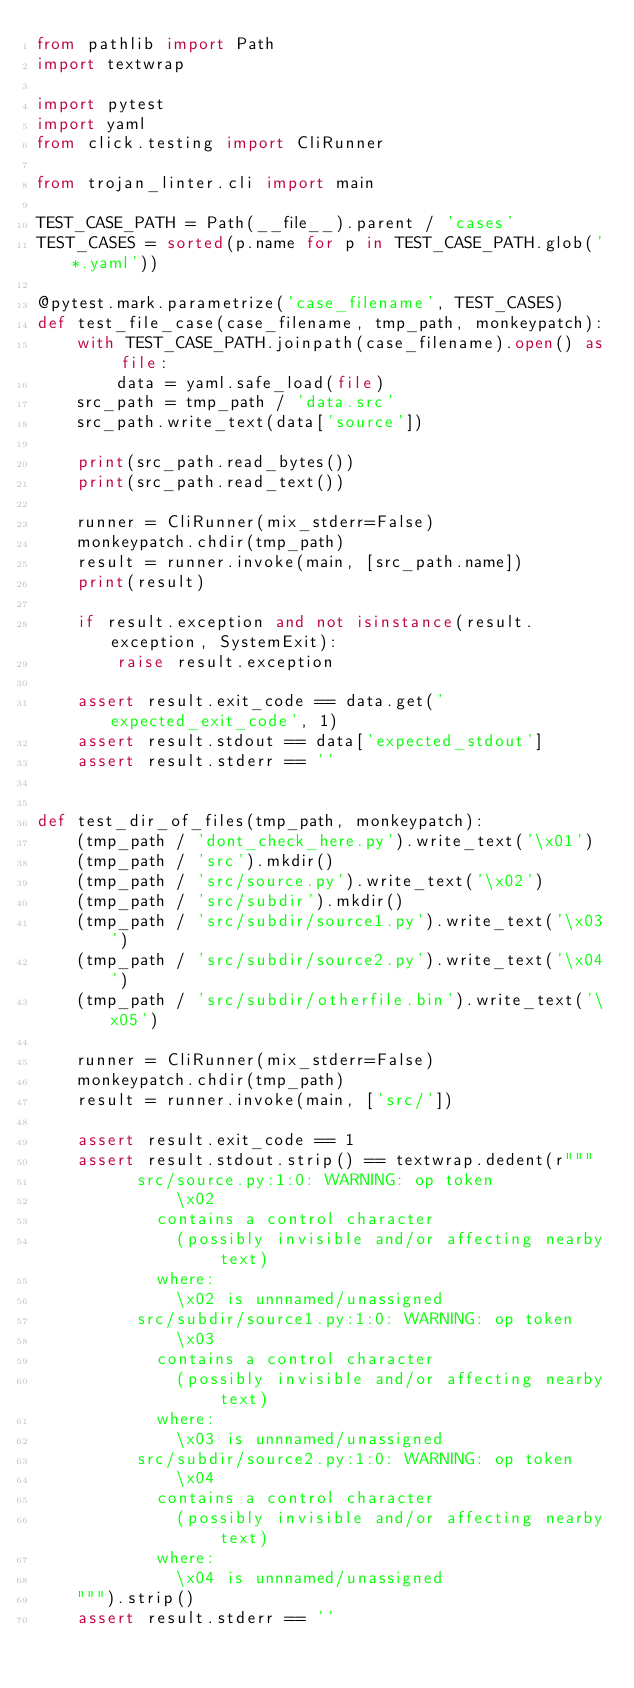Convert code to text. <code><loc_0><loc_0><loc_500><loc_500><_Python_>from pathlib import Path
import textwrap

import pytest
import yaml
from click.testing import CliRunner

from trojan_linter.cli import main

TEST_CASE_PATH = Path(__file__).parent / 'cases'
TEST_CASES = sorted(p.name for p in TEST_CASE_PATH.glob('*.yaml'))

@pytest.mark.parametrize('case_filename', TEST_CASES)
def test_file_case(case_filename, tmp_path, monkeypatch):
    with TEST_CASE_PATH.joinpath(case_filename).open() as file:
        data = yaml.safe_load(file)
    src_path = tmp_path / 'data.src'
    src_path.write_text(data['source'])

    print(src_path.read_bytes())
    print(src_path.read_text())

    runner = CliRunner(mix_stderr=False)
    monkeypatch.chdir(tmp_path)
    result = runner.invoke(main, [src_path.name])
    print(result)

    if result.exception and not isinstance(result.exception, SystemExit):
        raise result.exception

    assert result.exit_code == data.get('expected_exit_code', 1)
    assert result.stdout == data['expected_stdout']
    assert result.stderr == ''


def test_dir_of_files(tmp_path, monkeypatch):
    (tmp_path / 'dont_check_here.py').write_text('\x01')
    (tmp_path / 'src').mkdir()
    (tmp_path / 'src/source.py').write_text('\x02')
    (tmp_path / 'src/subdir').mkdir()
    (tmp_path / 'src/subdir/source1.py').write_text('\x03')
    (tmp_path / 'src/subdir/source2.py').write_text('\x04')
    (tmp_path / 'src/subdir/otherfile.bin').write_text('\x05')

    runner = CliRunner(mix_stderr=False)
    monkeypatch.chdir(tmp_path)
    result = runner.invoke(main, ['src/'])

    assert result.exit_code == 1
    assert result.stdout.strip() == textwrap.dedent(r"""
          src/source.py:1:0: WARNING: op token
              \x02
            contains a control character
              (possibly invisible and/or affecting nearby text)
            where:
              \x02 is unnnamed/unassigned
          src/subdir/source1.py:1:0: WARNING: op token
              \x03
            contains a control character
              (possibly invisible and/or affecting nearby text)
            where:
              \x03 is unnnamed/unassigned
          src/subdir/source2.py:1:0: WARNING: op token
              \x04
            contains a control character
              (possibly invisible and/or affecting nearby text)
            where:
              \x04 is unnnamed/unassigned
    """).strip()
    assert result.stderr == ''
</code> 